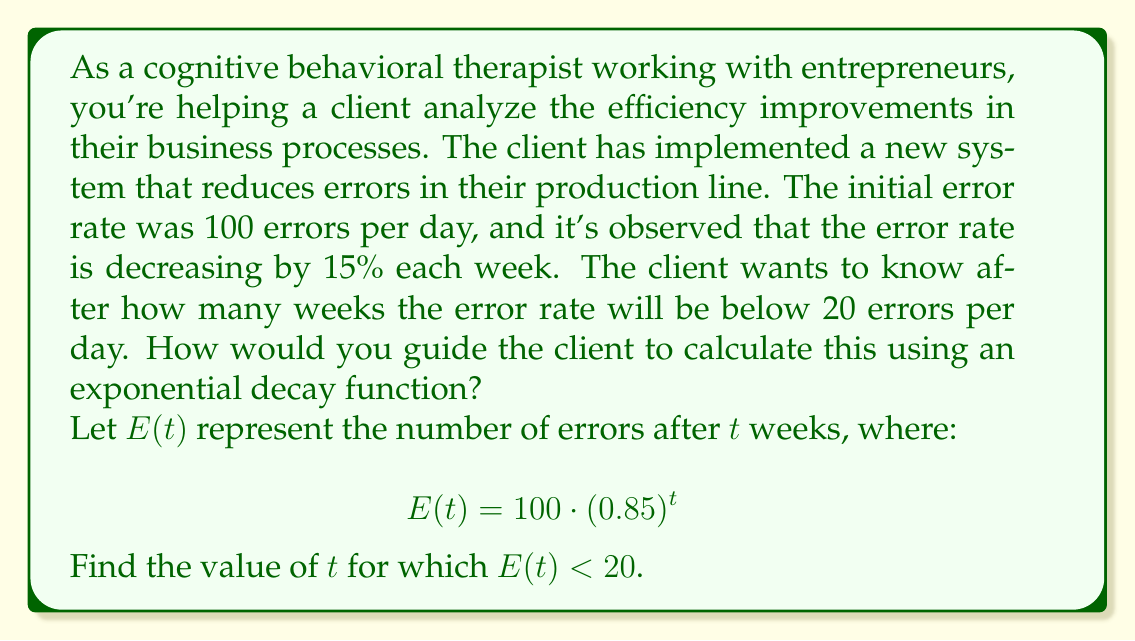Show me your answer to this math problem. To solve this problem, we'll guide the client through the following steps:

1) We start with the exponential decay function:
   $$E(t) = 100 \cdot (0.85)^t$$

2) We want to find $t$ when $E(t) < 20$. So, we set up the inequality:
   $$100 \cdot (0.85)^t < 20$$

3) Divide both sides by 100:
   $$(0.85)^t < 0.2$$

4) Take the natural logarithm of both sides:
   $$\ln((0.85)^t) < \ln(0.2)$$

5) Use the logarithm property $\ln(a^b) = b\ln(a)$:
   $$t \cdot \ln(0.85) < \ln(0.2)$$

6) Divide both sides by $\ln(0.85)$ (note that $\ln(0.85)$ is negative, so the inequality sign flips):
   $$t > \frac{\ln(0.2)}{\ln(0.85)}$$

7) Calculate the right side:
   $$t > \frac{\ln(0.2)}{\ln(0.85)} \approx 10.04$$

8) Since $t$ represents weeks and must be a whole number, we round up to the next integer.

This mathematical approach provides a concrete answer to help reduce the client's anxiety about the timeline for improvement. It gives a clear goal to work towards and can be used to set realistic expectations.
Answer: The error rate will be below 20 errors per day after 11 weeks. 